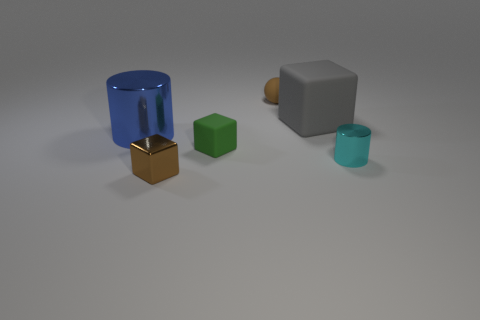How many other objects are the same color as the metal cube?
Ensure brevity in your answer.  1. What number of matte objects are the same size as the ball?
Your answer should be very brief. 1. What size is the matte thing that is the same color as the shiny block?
Keep it short and to the point. Small. What size is the thing that is both in front of the green thing and right of the green rubber cube?
Give a very brief answer. Small. There is a big object on the left side of the tiny brown thing in front of the brown rubber sphere; how many big shiny things are to the left of it?
Offer a very short reply. 0. Are there any large rubber things of the same color as the big cylinder?
Your answer should be very brief. No. The cylinder that is the same size as the brown shiny thing is what color?
Give a very brief answer. Cyan. There is a small rubber thing in front of the cylinder that is behind the matte block that is left of the sphere; what is its shape?
Your response must be concise. Cube. There is a small brown thing in front of the tiny ball; how many cylinders are to the left of it?
Your answer should be compact. 1. Is the shape of the brown object right of the small brown metal object the same as the matte object that is on the left side of the brown ball?
Your answer should be very brief. No. 